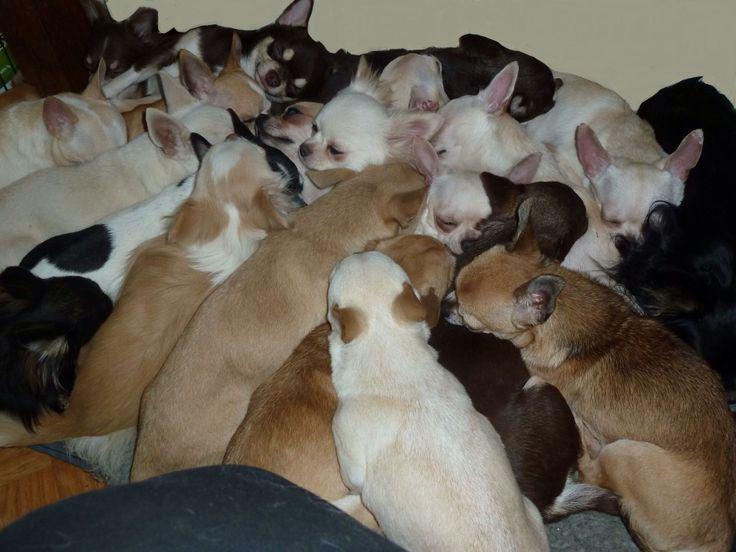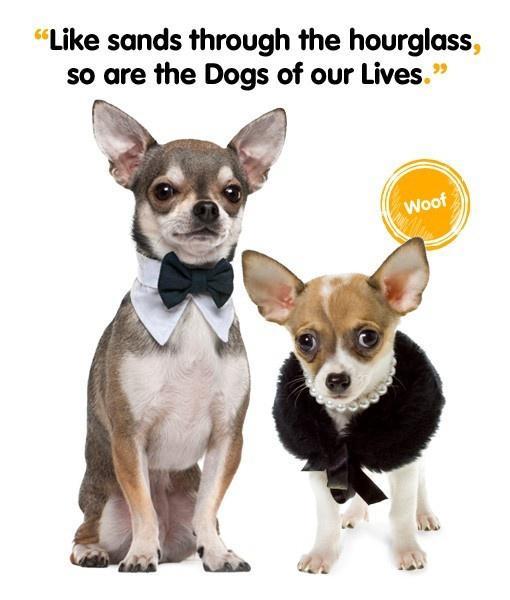The first image is the image on the left, the second image is the image on the right. Considering the images on both sides, is "One of the images shows exactly two dogs." valid? Answer yes or no. Yes. The first image is the image on the left, the second image is the image on the right. For the images shown, is this caption "An image shows exactly two dogs wearing fancy garb." true? Answer yes or no. Yes. The first image is the image on the left, the second image is the image on the right. Examine the images to the left and right. Is the description "An equal number of puppies are in each image." accurate? Answer yes or no. No. The first image is the image on the left, the second image is the image on the right. Analyze the images presented: Is the assertion "Only one image shows dogs wearing some kind of attire besides an ordinary dog collar." valid? Answer yes or no. Yes. 